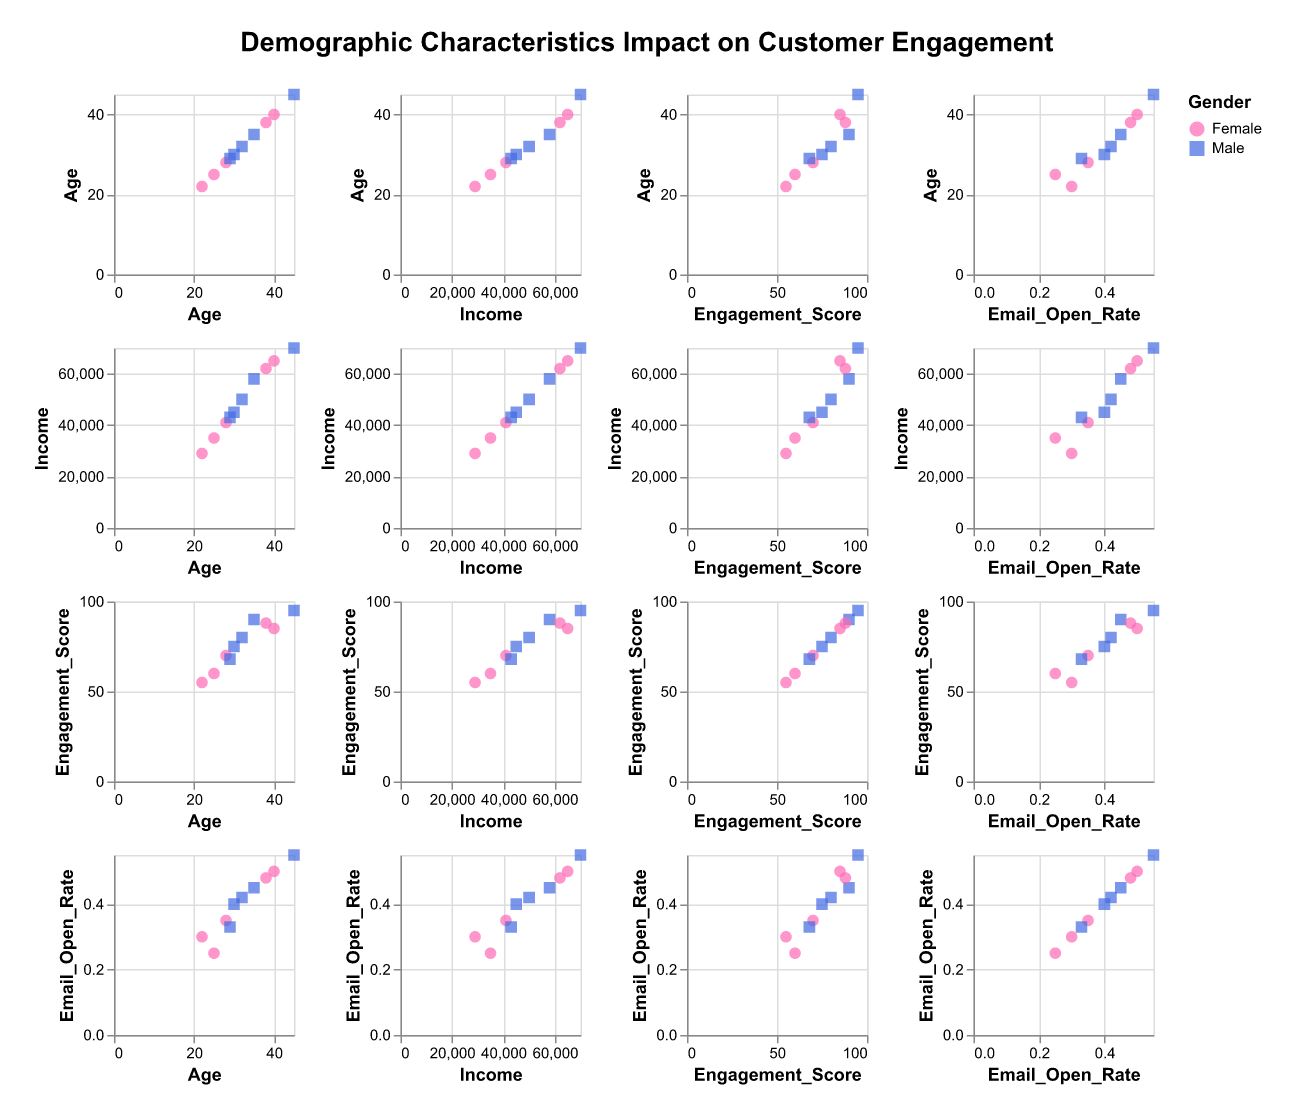What is the title of the scatter plot matrix? The title is found at the top of the scatter plot matrix and provides an overview of the data being visualized.
Answer: Demographic Characteristics Impact on Customer Engagement How many data points are represented in each scatter plot? Each scatter plot shows the same number of data points since they are parts of a single dataset. Reviewing the data, it indicates there are 10 entries.
Answer: 10 What colors represent the different genders in the scatter plot matrix? The scatter plot uses two distinct colors to represent genders: magenta for Female and blue for Male.
Answer: Magenta (Female) and Blue (Male) What is the relationship between Age and Engagement Score? Observing the scatter plot where Age is on one axis and Engagement Score on the other, one can see a pattern or trend of points. The explanation would look for a positive or negative correlation.
Answer: Positive correlation Which has a higher Email Open Rate: a Male aged 40 or a Female aged 40? By looking at the scatter plots involving Age, Email Open Rate, and Gender, identify the Male and Female points for Age 40 and compare their Email Open Rates.
Answer: Female aged 40 Is there a visible trend between Income and Email Open Rate? Review the scatter plot with Income on one axis and Email Open Rate on the other. Look for any upward or downward trends or patterns in the data points.
Answer: Positive trend Are the data points evenly distributed across the plot matrix? Examine the scatter plots for clustering or gaps in data points to determine if they are evenly distributed or tend to cluster within certain areas.
Answer: Not evenly distributed How does Gender affect Engagement Score? Compare the spread and clustering of data points by gender in the scatter plots involving Engagement Score. Note the differences between male and female data point distributions.
Answer: Higher among Males Which demographic has the highest Income and what is their Engagement Score? Identify the highest point on the Income axis and check the corresponding Engagement Score and Gender in the tooltip.
Answer: Male, Age 45, Engagement Score 95 What age group has the highest range of Income in the dataset? Examine the plots that have Age and Income on their axes, then compare the range of income values across different ages to identify the group with the highest span.
Answer: Age group around 45 How do the Email Open Rates differ between Males and Females? Use scatter plots involving Email Open Rate and Gender to compare the distributions and averages of Email Open Rates between Males and Females.
Answer: Males generally have higher email open rates 